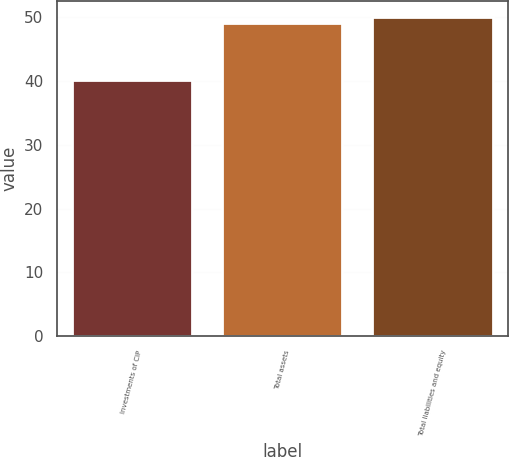<chart> <loc_0><loc_0><loc_500><loc_500><bar_chart><fcel>Investments of CIP<fcel>Total assets<fcel>Total liabilities and equity<nl><fcel>40.1<fcel>49.1<fcel>50<nl></chart> 